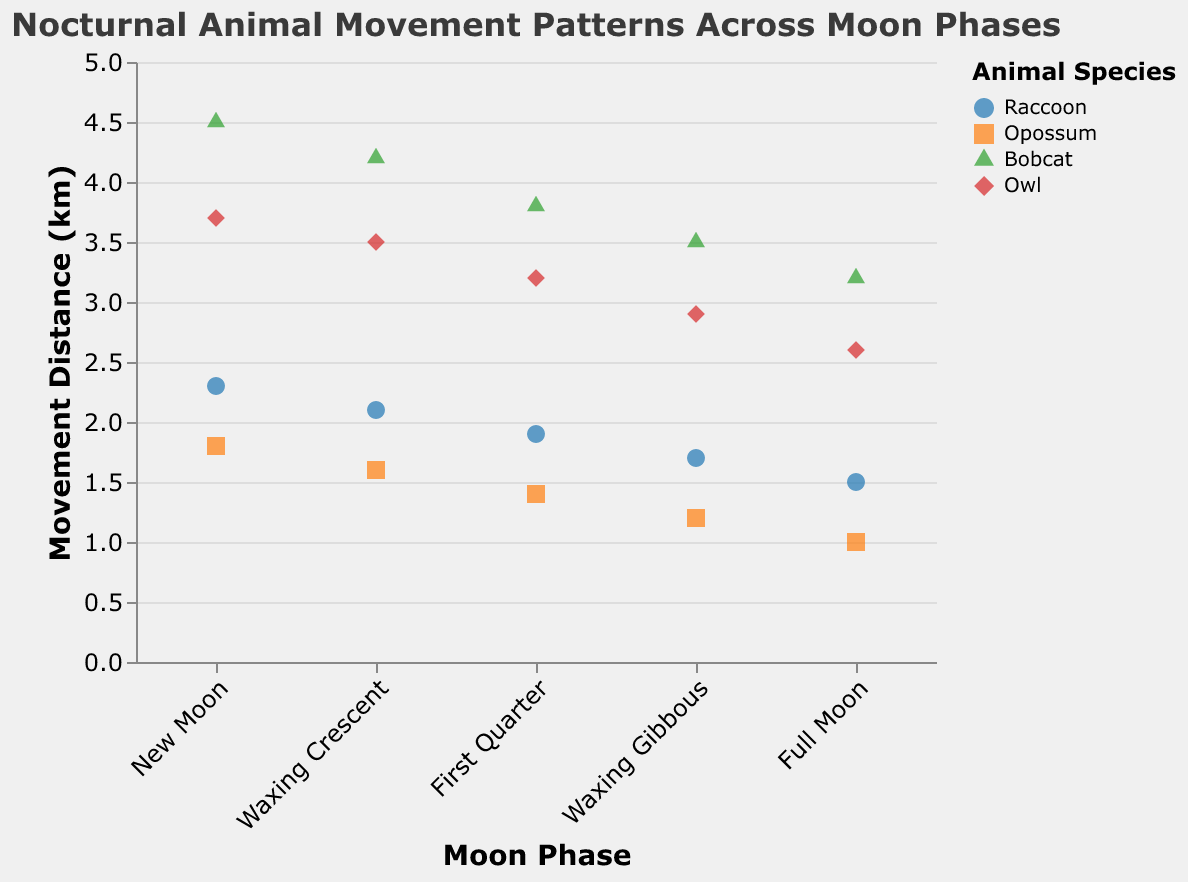What's the title of the figure? The title is shown at the top of the figure. It reads "Nocturnal Animal Movement Patterns Across Moon Phases".
Answer: Nocturnal Animal Movement Patterns Across Moon Phases What is the movement distance range displayed on the y-axis? The y-axis represents the movement distance in kilometers, and its scale ranges from 0 to 5 kilometers.
Answer: 0 to 5 km Which animal species moved the farthest during the New Moon phase? Looking at the data points for the New Moon phase, the Bobcat has the highest movement distance of 4.5 kilometers.
Answer: Bobcat In which moon phase do raccoons have the shortest movement distance? The movement distances for raccoons in each phase are 2.3, 2.1, 1.9, 1.7, and 1.5 km. The shortest is 1.5 km during the Full Moon phase.
Answer: Full Moon Compare the movement distances of opossums between the Waxing Crescent and First Quarter phases. The movement distance of opossums during the Waxing Crescent phase is 1.6 km, and during the First Quarter phase, it is 1.4 km. Therefore, they moved less during the First Quarter phase.
Answer: First Quarter What is the average movement distance of owls across all moon phases? The movement distances for owls are 3.7, 3.5, 3.2, 2.9, and 2.6 km. Average = (3.7 + 3.5 + 3.2 + 2.9 + 2.6) / 5 = 3.18 km.
Answer: 3.18 km Which moon phase shows the least variation in movement distances among animal species? Observing the different phases, the Full Moon phase has the smallest range from 1.0 km to 3.2 km, illustrating the least variation.
Answer: Full Moon How does the movement distance of bobcats during the Full Moon compare to their movement during the New Moon? Bobcats move 3.2 km during the Full Moon and 4.5 km during the New Moon. They move less during the Full Moon.
Answer: Less during Full Moon Which animal species consistently shows a decrease in movement distance as the moon phases progress from New Moon to Full Moon? Both the raccoon and the opossum species show a consistent decrease in movement distance from New Moon to Full Moon.
Answer: Raccoon and Opossum 